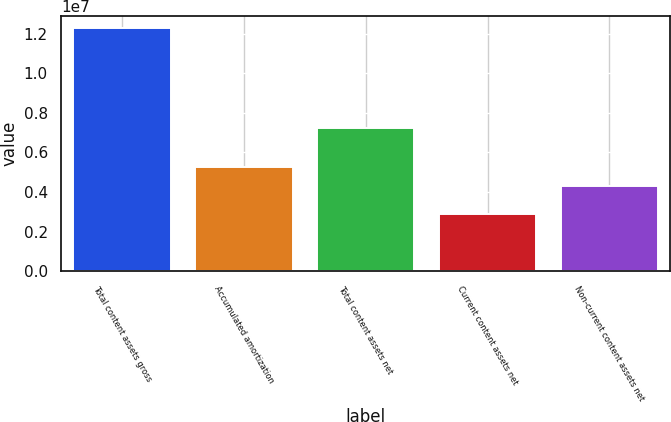Convert chart to OTSL. <chart><loc_0><loc_0><loc_500><loc_500><bar_chart><fcel>Total content assets gross<fcel>Accumulated amortization<fcel>Total content assets net<fcel>Current content assets net<fcel>Non-current content assets net<nl><fcel>1.22841e+07<fcel>5.25063e+06<fcel>7.21882e+06<fcel>2.906e+06<fcel>4.31282e+06<nl></chart> 